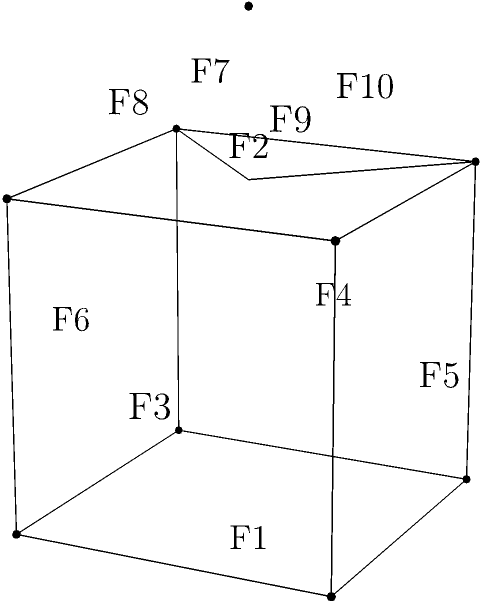In a 3D platformer game level, you encounter a unique structure resembling a cube with a pyramid on top, as shown in the diagram. Determine the Euler characteristic of this polyhedron and explain how it relates to the general formula for convex polyhedra. To find the Euler characteristic and relate it to the general formula, let's follow these steps:

1) Count the number of vertices (V):
   - 8 vertices from the cube
   - 1 vertex at the top of the pyramid
   Total V = 9

2) Count the number of edges (E):
   - 12 edges from the cube
   - 4 edges connecting the top vertex to the cube
   Total E = 16

3) Count the number of faces (F):
   - 6 faces from the cube
   - 4 triangular faces from the pyramid
   Total F = 10

4) Calculate the Euler characteristic (χ) using the formula:
   χ = V - E + F
   χ = 9 - 16 + 10 = 3

5) Relate to the general formula:
   The Euler characteristic for convex polyhedra is always 2.
   Our result (3) differs because this shape is not a simple convex polyhedron.

6) Explanation of the difference:
   The structure is composed of two polyhedra (a cube and a pyramid) sharing a face.
   When we combine them, we're essentially adding their Euler characteristics and subtracting 2 for the shared face:
   χ(cube) + χ(pyramid) - 2 = 2 + 2 - 2 = 2

   The extra 1 in our result (3 instead of 2) comes from the fact that we've counted the shared face twice in our calculation, once for the cube and once for the pyramid base.
Answer: Euler characteristic is 3, differing from 2 due to shared face counted twice. 